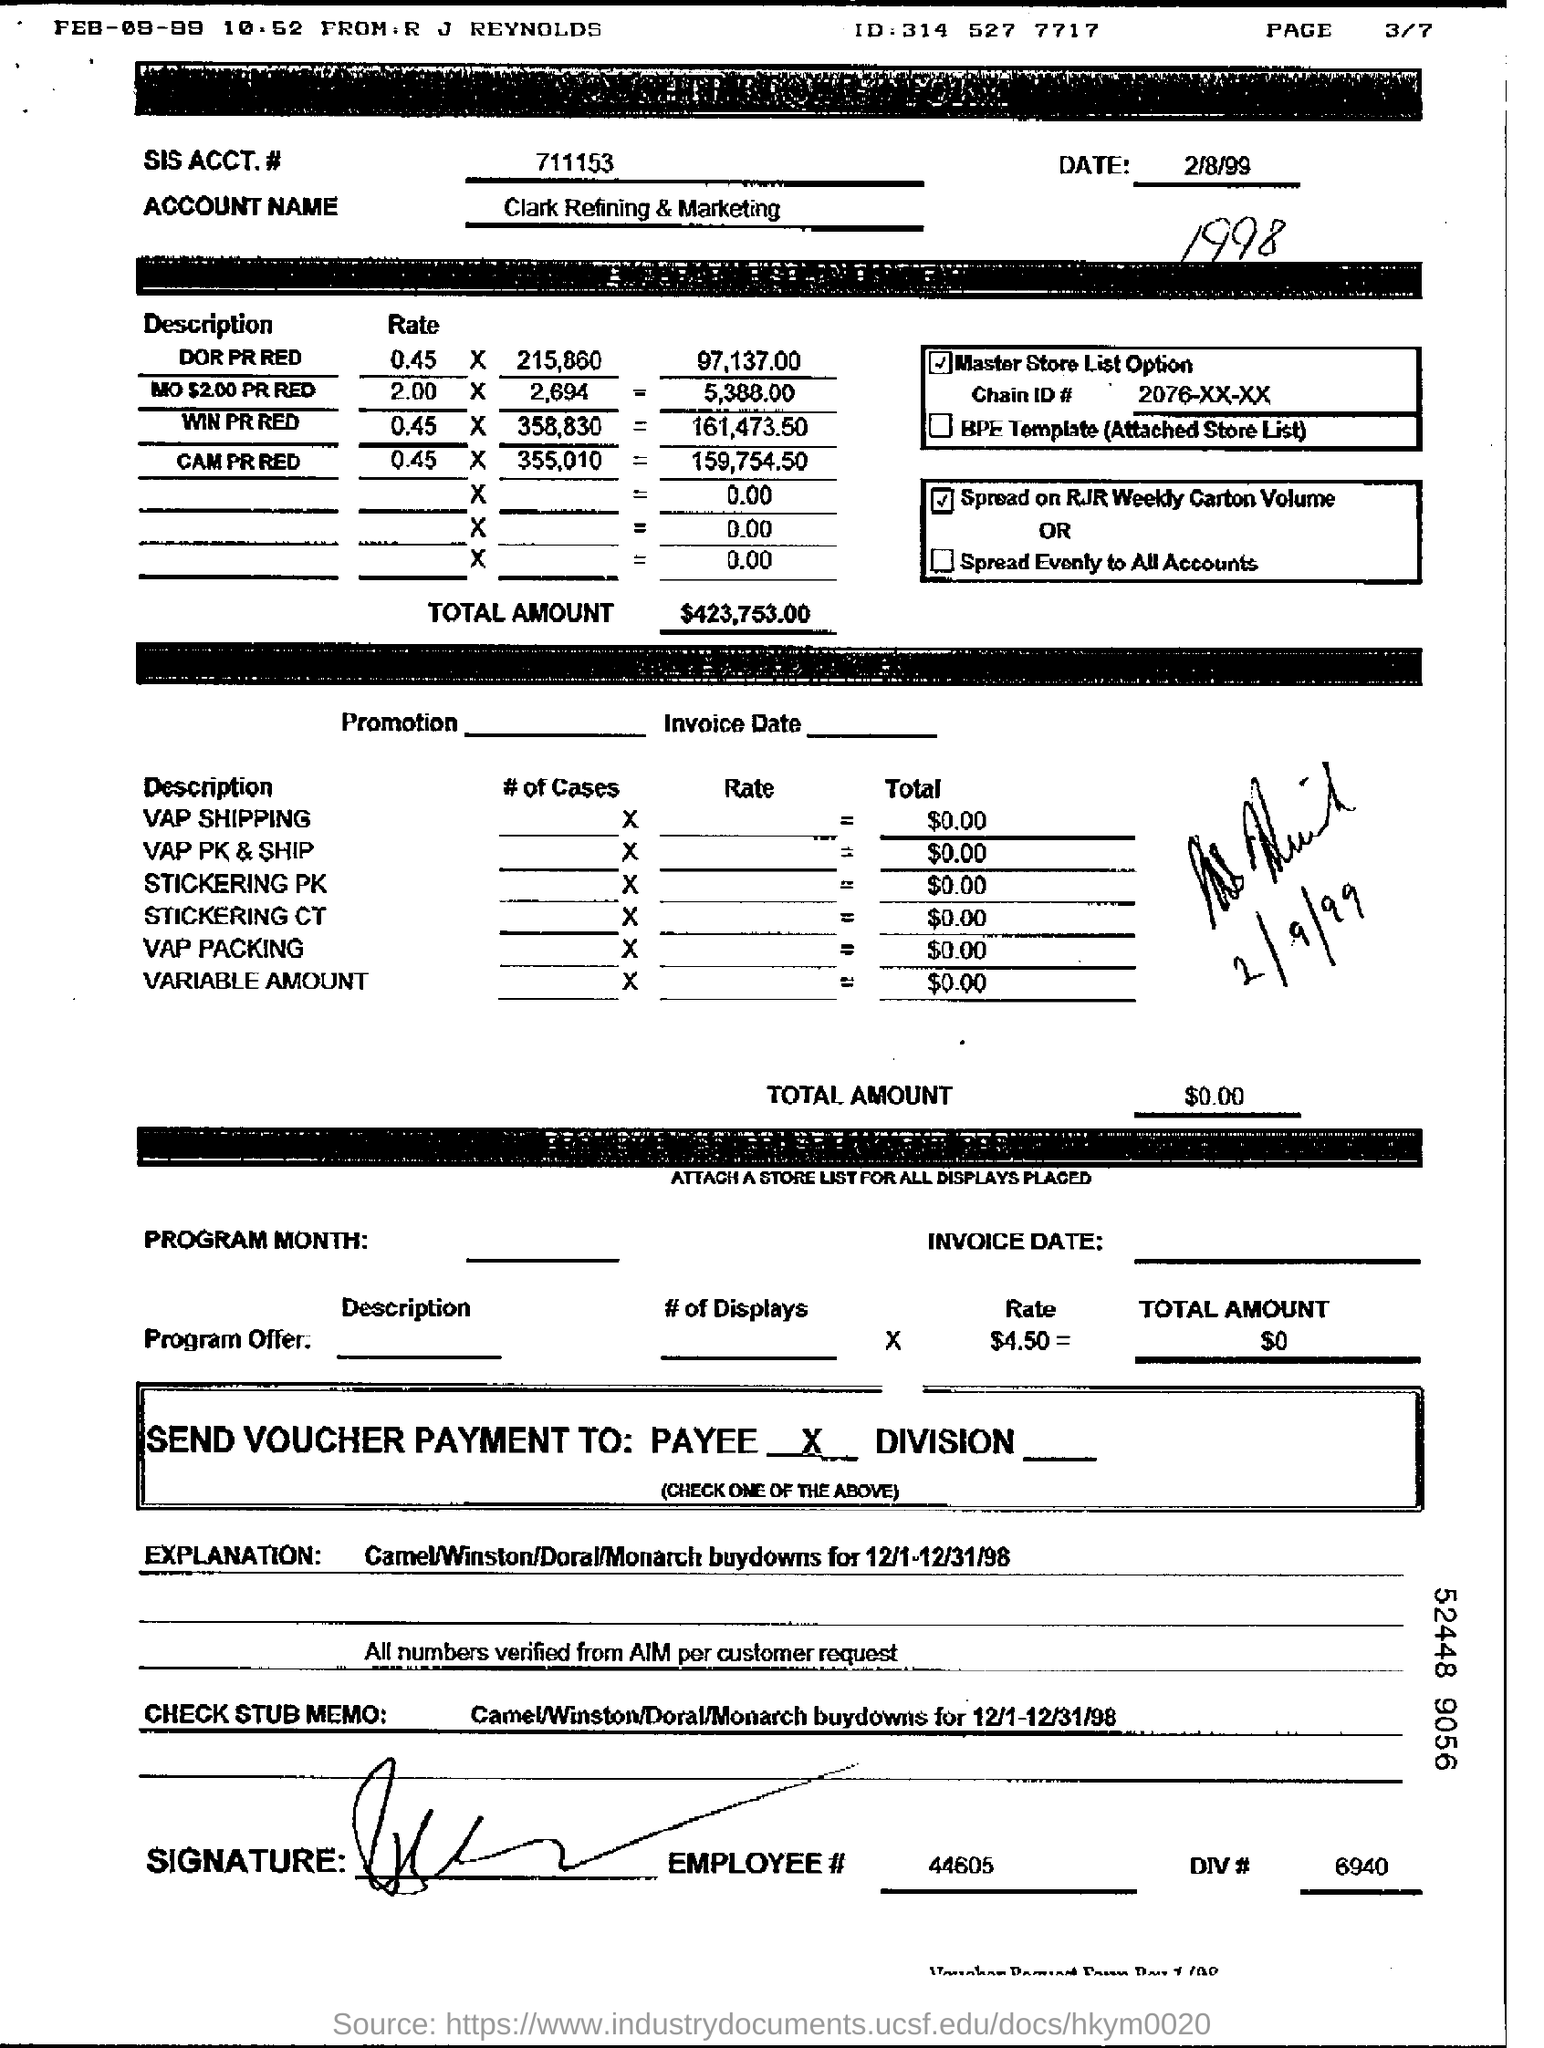What is the EMPLOYEE  # number mentioned at the bottom?
Your response must be concise. 44605. What is the date mentioned?
Your response must be concise. 2/8/99. What is the ACCOUNT NAME?
Your answer should be compact. Clark Refining & Marketing. What is the SIS ACCT# given in the form?
Your answer should be very brief. 711153. 